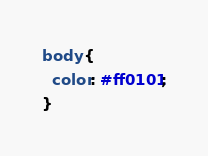Convert code to text. <code><loc_0><loc_0><loc_500><loc_500><_CSS_>body {
  color: #ff0101;
}
</code> 